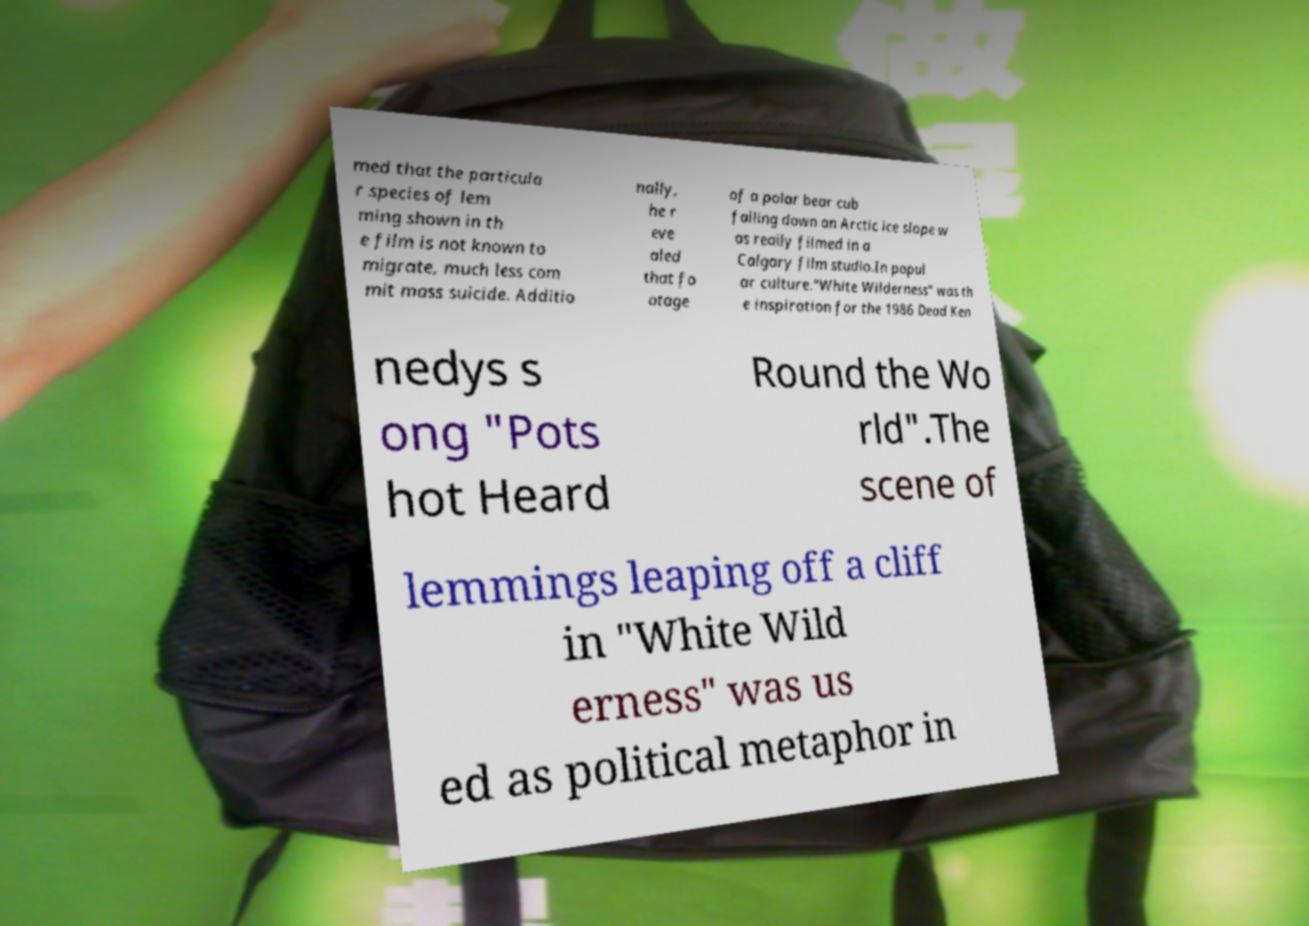For documentation purposes, I need the text within this image transcribed. Could you provide that? med that the particula r species of lem ming shown in th e film is not known to migrate, much less com mit mass suicide. Additio nally, he r eve aled that fo otage of a polar bear cub falling down an Arctic ice slope w as really filmed in a Calgary film studio.In popul ar culture."White Wilderness" was th e inspiration for the 1986 Dead Ken nedys s ong "Pots hot Heard Round the Wo rld".The scene of lemmings leaping off a cliff in "White Wild erness" was us ed as political metaphor in 